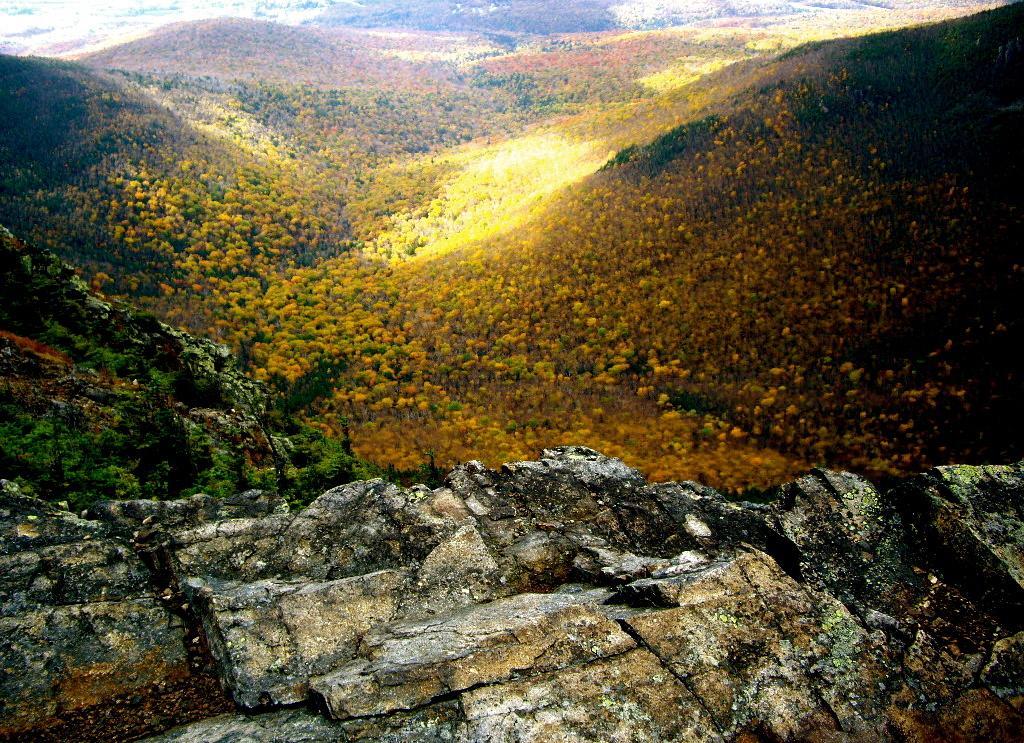Please provide a concise description of this image. In this picture we can see few rocks, trees and hills. 